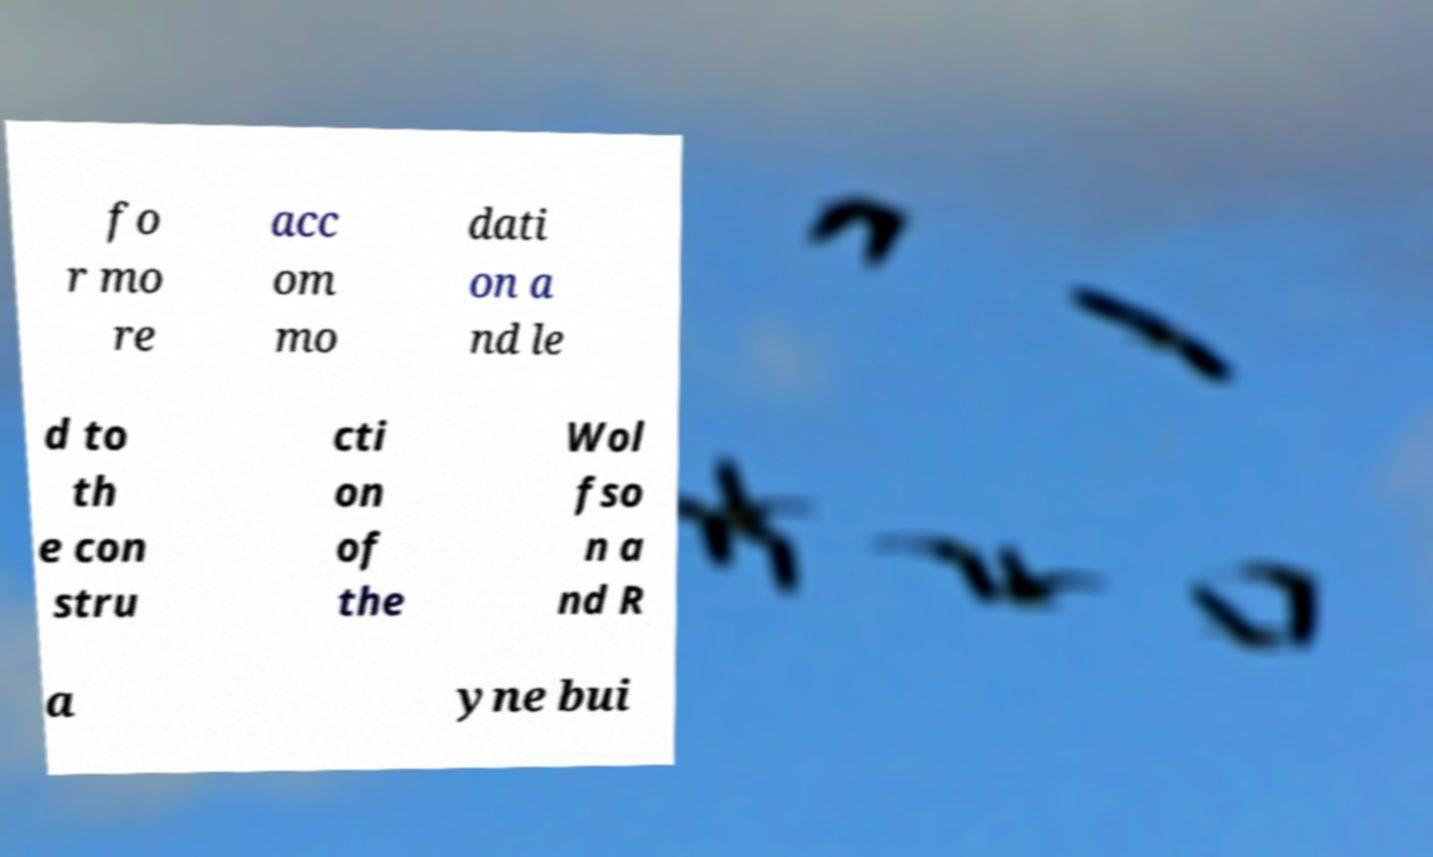Can you accurately transcribe the text from the provided image for me? fo r mo re acc om mo dati on a nd le d to th e con stru cti on of the Wol fso n a nd R a yne bui 